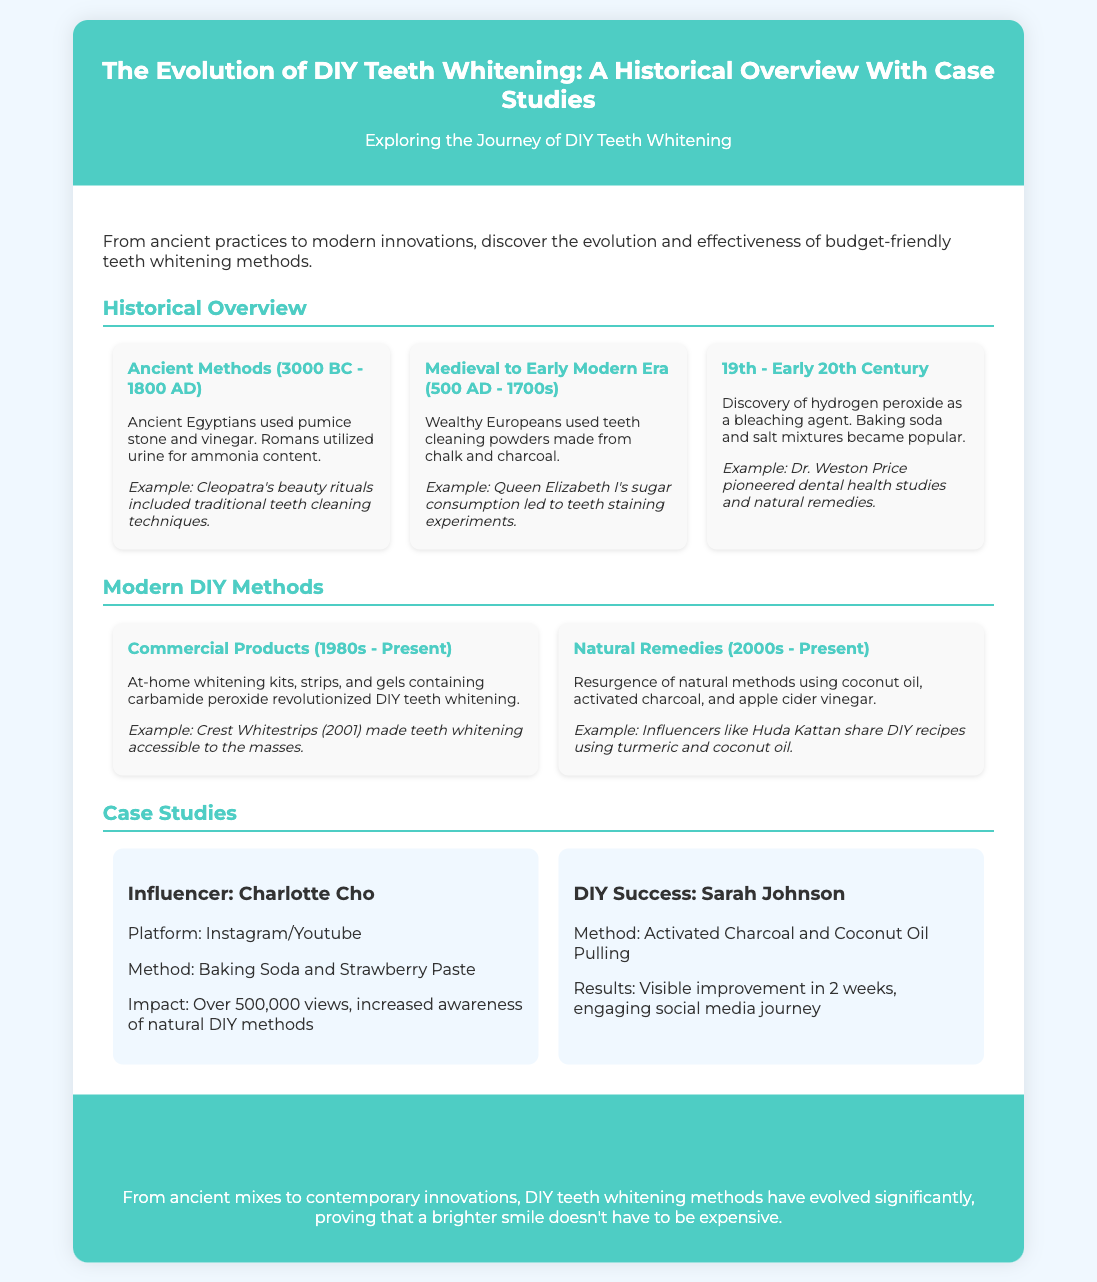What methods did Ancient Egyptians use for teeth whitening? The document states that Ancient Egyptians used pumice stone and vinegar for teeth whitening.
Answer: Pumice stone and vinegar Who utilized urine for teeth whitening? The document mentions that Romans utilized urine for its ammonia content in teeth whitening.
Answer: Romans What did wealthy Europeans use in the Medieval era? According to the document, wealthy Europeans used teeth cleaning powders made from chalk and charcoal.
Answer: Teeth cleaning powders made from chalk and charcoal Which commercial product made teeth whitening accessible to the masses? The document highlights Crest Whitestrips from 2001 as a product that made teeth whitening accessible to the masses.
Answer: Crest Whitestrips What resurgence in DIY methods is mentioned in the modern section? The document notes the resurgence of natural methods using coconut oil, activated charcoal, and apple cider vinegar.
Answer: Natural methods using coconut oil, activated charcoal, and apple cider vinegar What was the impact of Charlotte Cho's method? The document indicates that Charlotte Cho's method had over 500,000 views, increasing awareness of natural DIY methods.
Answer: Over 500,000 views Who is an example of a DIY success story mentioned? The document mentions Sarah Johnson as an example of a DIY success story.
Answer: Sarah Johnson What is the key conclusion about DIY teeth whitening methods? The document concludes that DIY teeth whitening methods have evolved, proving they are affordable and effective.
Answer: Affordable and effective 